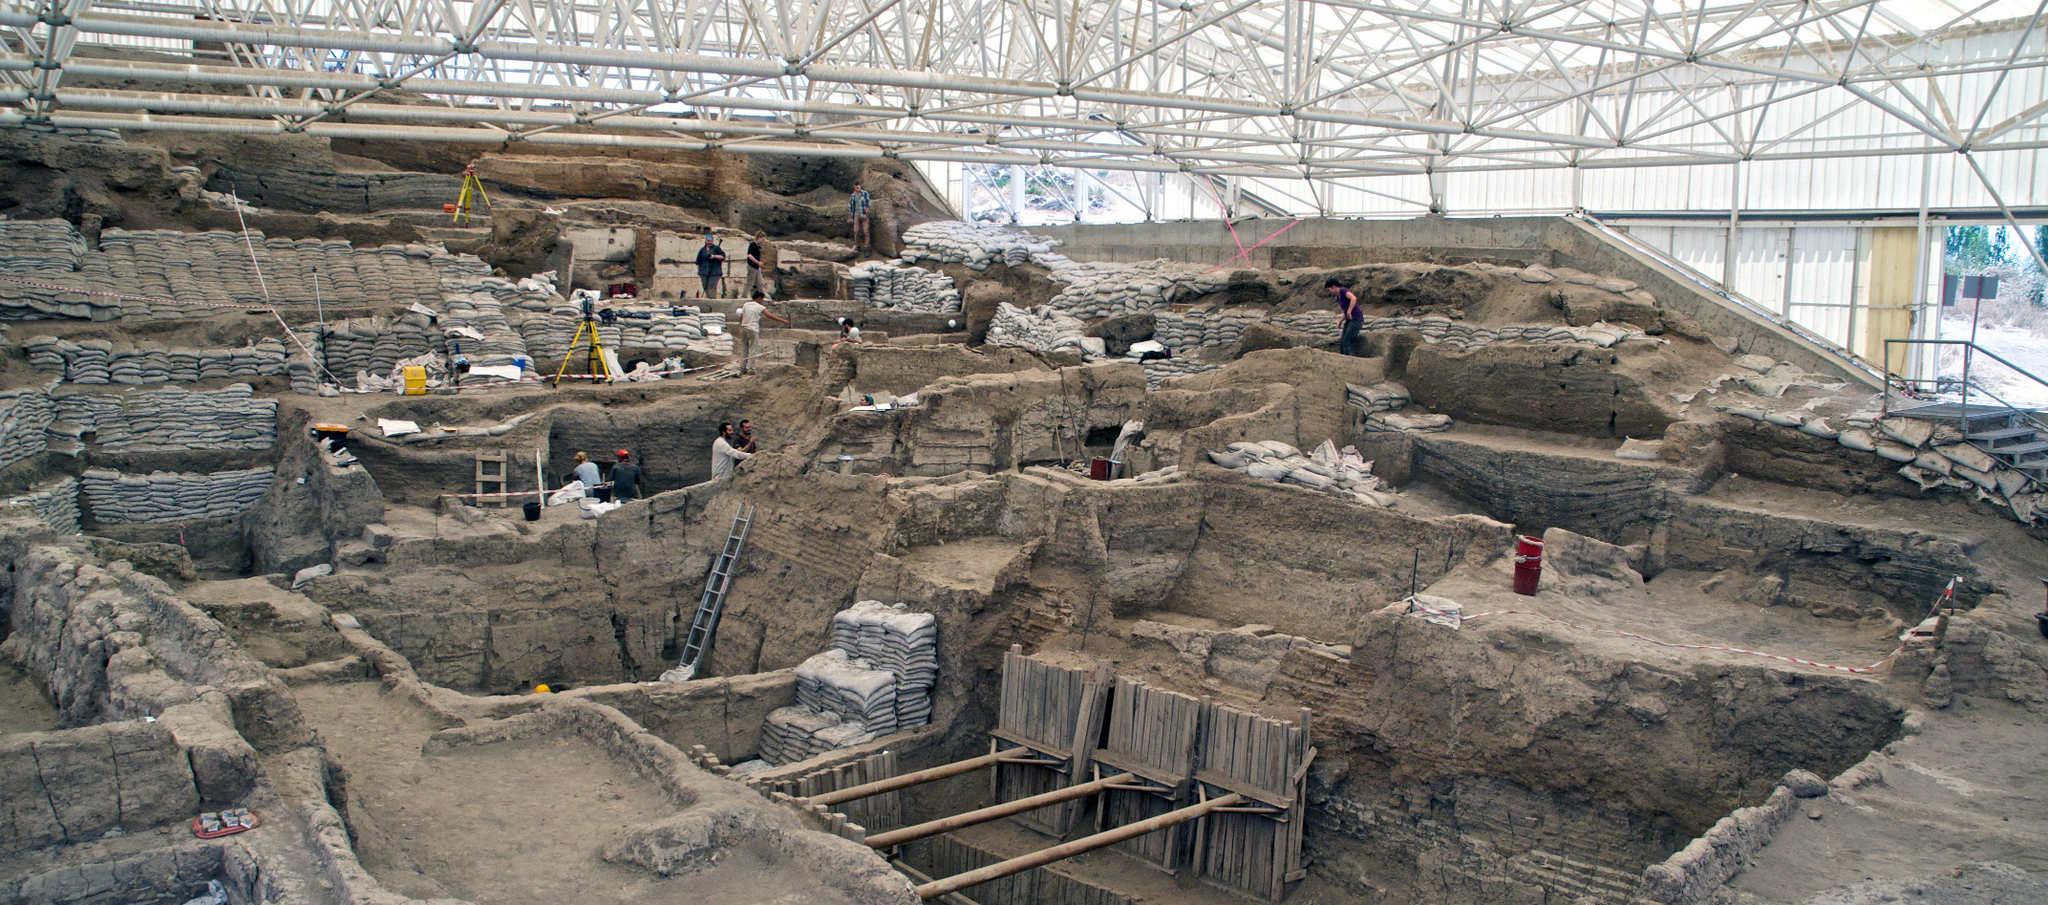Can you write a short story imagining life in this ancient settlement? In the early hours of dawn, Layla woke to the gentle hum of her family bustling about their home. Her mother was already at the hearth, stirring a pot of stew made from the grains and vegetables harvested from their modest plot outside the settlement. Layla’s father and brothers were preparing their tools for a morning hunt, their whispered plans filling the room with a sense of anticipation.

As the sun climbed higher, Layla joined the other women in communal tasks, weaving baskets and shaping clay pots. Their work was accompanied by songs and stories passed down through generations, each woven thread and molded pot a testament to their rich cultural heritage. In the afternoon, the marketplace buzzed with traders and artisans showcasing their goods – vibrant textiles, intricately carved tools, and exotic spices from distant lands. Layla delighted in the diversity of the marketplace, learning about the world beyond her own community through the stories of traveling merchants.

As evening approached, the settlement gathered for a communal feast. The aroma of roast meat mingled with the scent of flowers adorning the gathering space, children’s laughter blending with the rhythmic beats of drums. Elders recounted tales of ancestors, invoking the spirits and lessons of the past, while the community bonded over shared food and traditions. Layla felt a profound connection to her ancestors and their land, cherishing the strength and unity that defined her people’s way of life. Describe a day in the life of an archaeologist working at Çatalhöyük in modern times. A day in the life of an archaeologist at Çatalhöyük begins early in the morning, just as the sun starts to rise over the Turkish landscape. The team gathers around the site, reviewing the day's objectives and assignments. Equipped with tools and protective gear, they enter the sheltered excavation area, where the ancient ruins await their careful exploration.

The first task is to carefully remove layers of soil using brushes and small trowels, revealing new sections of the settlement. Each find is meticulously documented with photographs, sketches, and notes detailing its location and characteristics. Throughout the day, archaeologists often engage in lively discussions, sharing hypotheses about the artifacts and structures they uncover.

Around midday, the team breaks for a communal lunch, discussing their progress and plans under the shade of the roof. Afterward, some team members focus on cataloging and analyzing the morning's discoveries, while others continue the laborious task of excavation. They work methodically, knowing that even the smallest artifact could provide significant insights into Çatalhöyük’s history.

As the sun sets, the team wraps up their work, securing the site and packing away their tools. Evening meetings often involve reviewing the day's findings and planning for the next day's tasks. Despite the physical demands and sometimes painstakingly slow progress, the archaeologists are driven by a shared passion for uncovering the secrets of one of humanity’s earliest settlements, each discovery adding another piece to the intricate puzzle of our shared history. 